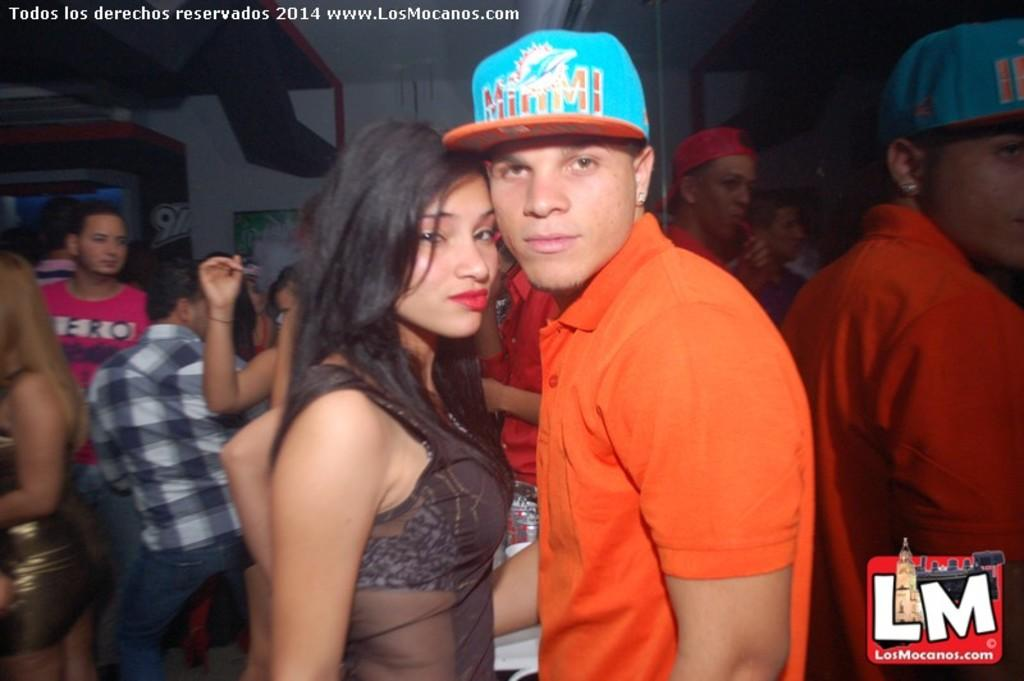<image>
Summarize the visual content of the image. An LM logo occupies the corner of a photo depicting a young couple. 